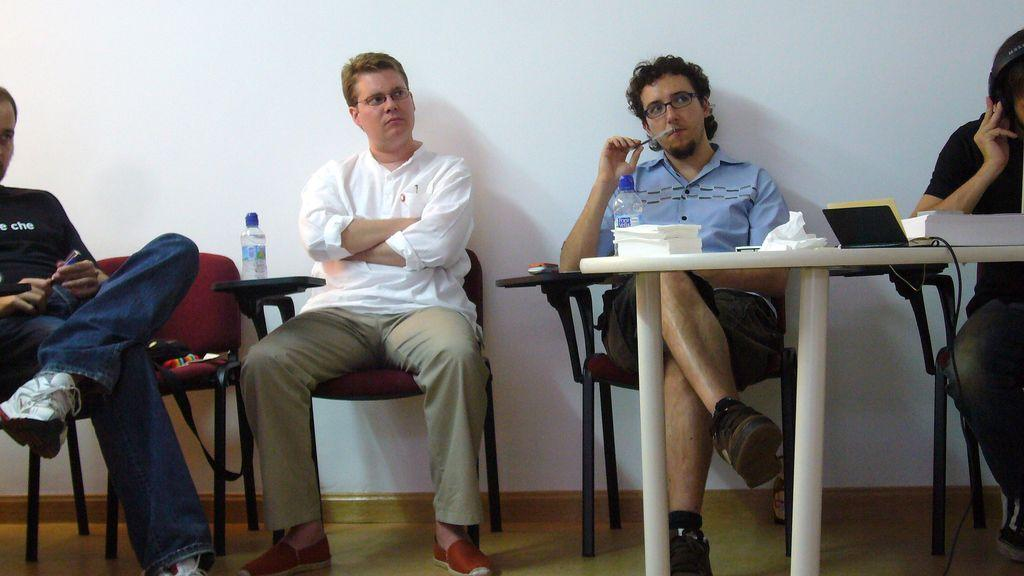How many men are sitting in the image? There are four men sitting on chairs in the image. What is in front of the men? There is a table in front of the men. What items can be seen on the table? Tissues, a water bottle, and a book are present on the table. What is behind the men? There is a wall behind the men. What type of leather is covering the chairs the men are sitting on? The chairs the men are sitting on are not described as being covered in leather, so we cannot determine the type of leather used. 